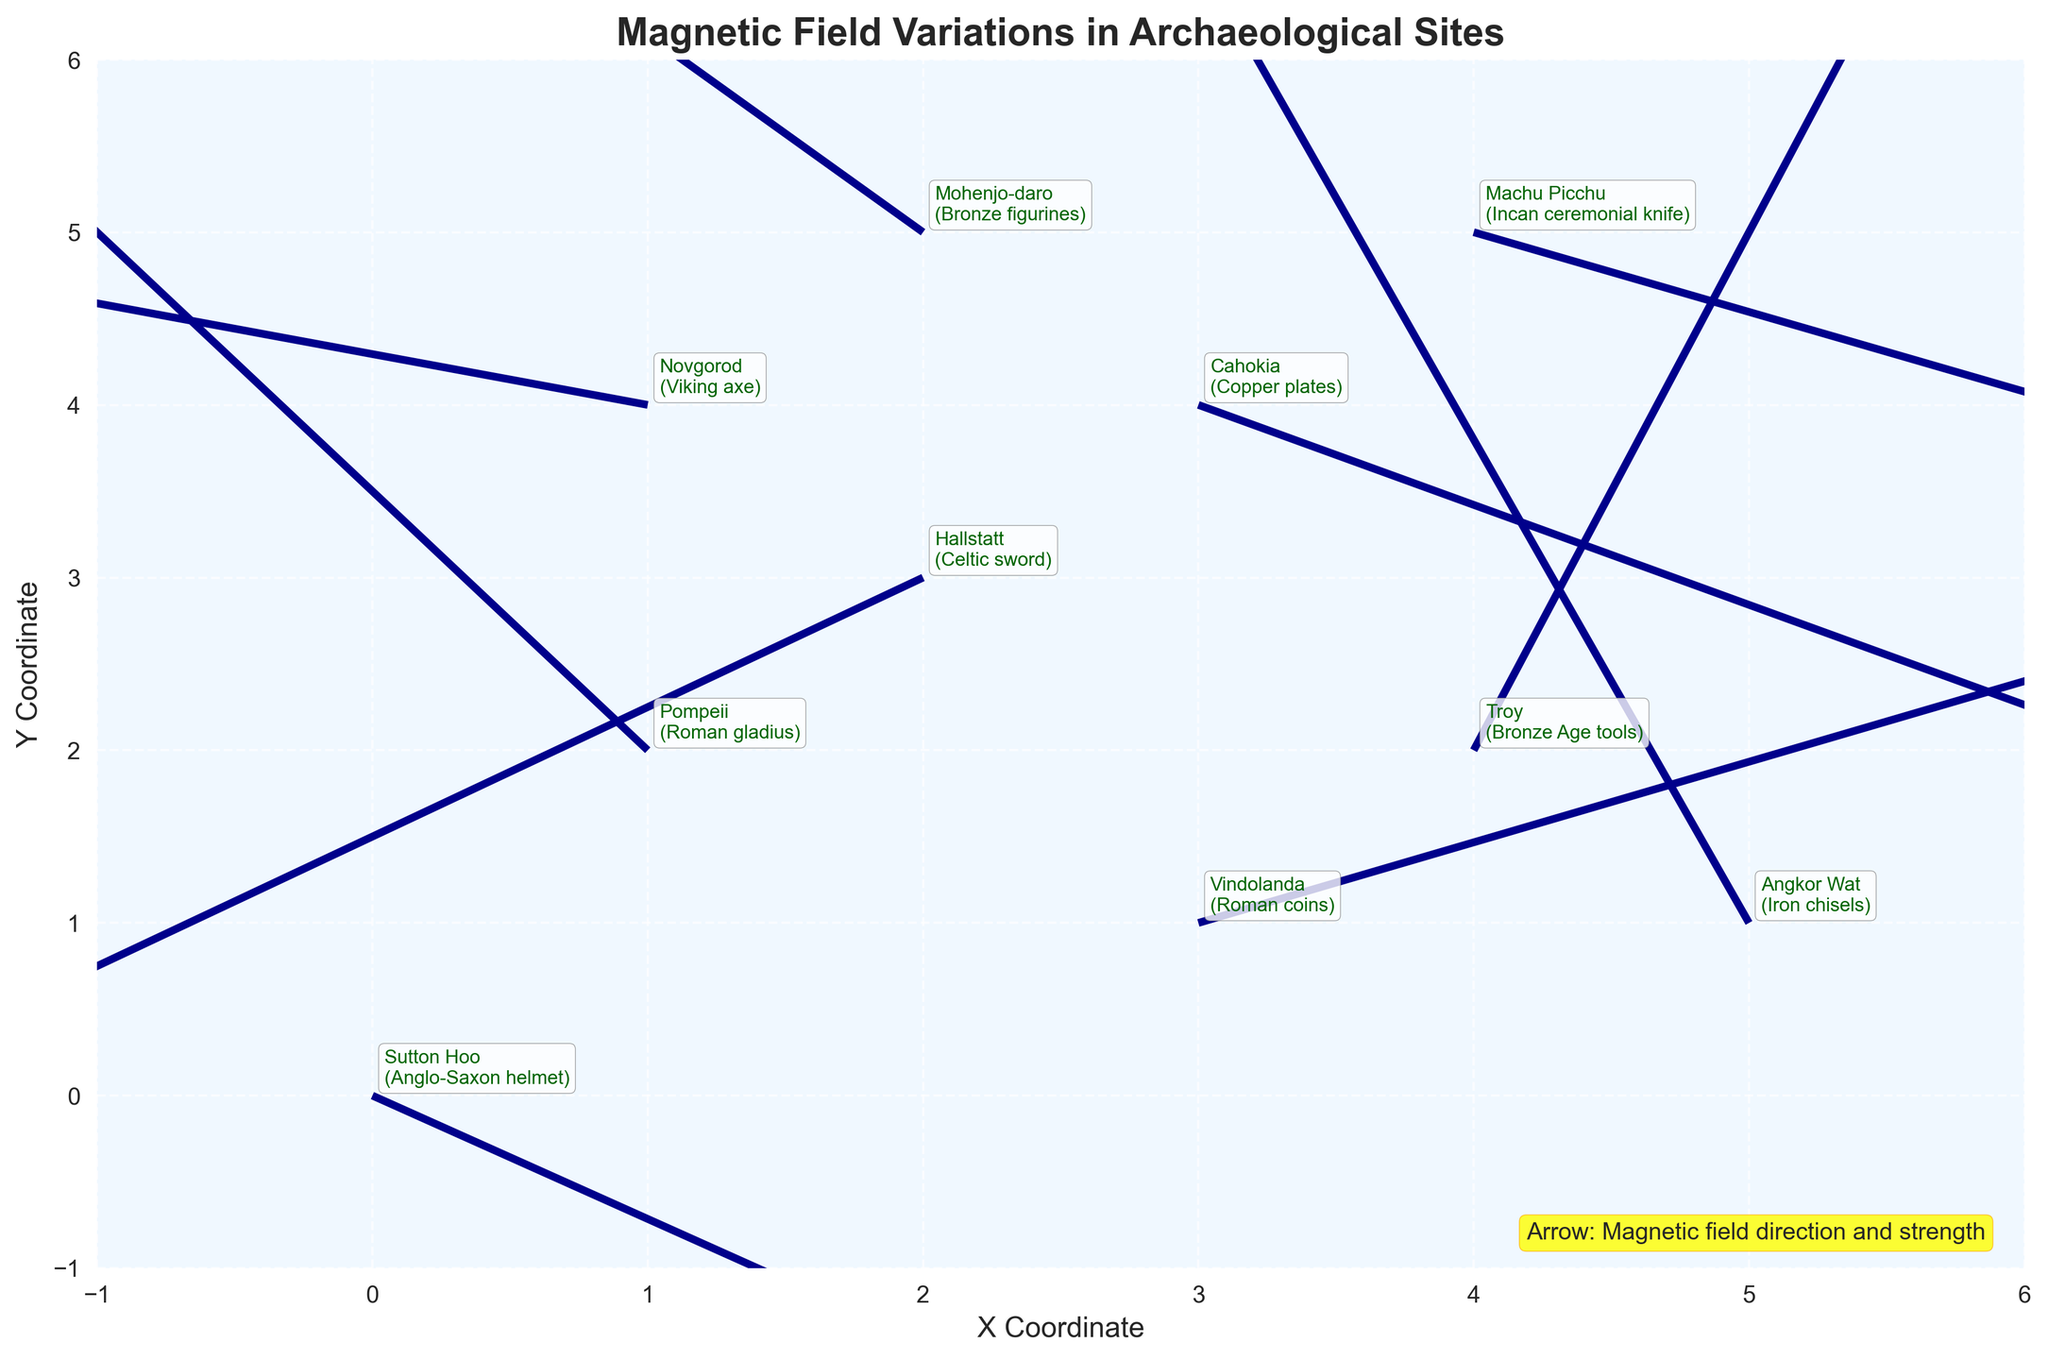What is the title of the figure? The title can be found at the top of the figure. It is usually in a larger font size and bold.
Answer: Magnetic Field Variations in Archaeological Sites What is the color of the background in the plot? The background color can be seen clearly as the coloring behind the data points and arrows.
Answer: Light blue Which measurement correlates to the site "Sutton Hoo"? You can locate "Sutton Hoo" by finding its label on the plot and seeing the corresponding coordinates.
Answer: (0, 0) Which site shows the largest vector magnitude? To find the largest vector magnitude, compare the lengths of the arrows in the plot.
Answer: Sutton Hoo What are the coordinates for the Pompeii site? Locate "Pompeii" on the plot to find its corresponding coordinates.
Answer: (1, 2) How many sites are plotted in the figure? Count all the individual labels indicating different sites.
Answer: 10 Between the sites "Hallstatt" and "Novgorod," which has a longer vector? Compare the vector lengths of these two sites by looking at their arrow lengths.
Answer: Novgorod What site is located at coordinates (3, 4)? Find the coordinates (3, 4) on the plot and refer to the site label there.
Answer: Cahokia Which site has an artifact listed as "Bronze Age tools"? Locate the artifact "Bronze Age tools" in the plot's annotations to find the associated site.
Answer: Troy What is the vector direction for the "Roman coins" artifact at Vindolanda? Look at the arrow direction at Vindolanda to determine the vector's direction.
Answer: Right and slightly upward 